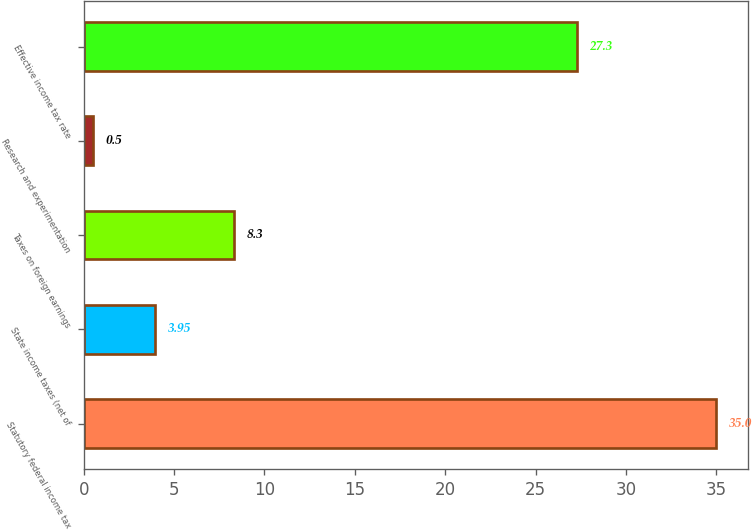Convert chart. <chart><loc_0><loc_0><loc_500><loc_500><bar_chart><fcel>Statutory federal income tax<fcel>State income taxes (net of<fcel>Taxes on foreign earnings<fcel>Research and experimentation<fcel>Effective income tax rate<nl><fcel>35<fcel>3.95<fcel>8.3<fcel>0.5<fcel>27.3<nl></chart> 